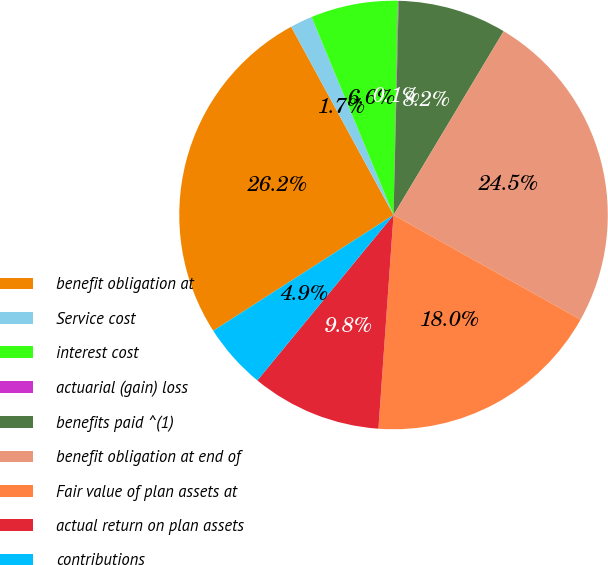Convert chart to OTSL. <chart><loc_0><loc_0><loc_500><loc_500><pie_chart><fcel>benefit obligation at<fcel>Service cost<fcel>interest cost<fcel>actuarial (gain) loss<fcel>benefits paid ^(1)<fcel>benefit obligation at end of<fcel>Fair value of plan assets at<fcel>actual return on plan assets<fcel>contributions<nl><fcel>26.16%<fcel>1.68%<fcel>6.58%<fcel>0.05%<fcel>8.21%<fcel>24.53%<fcel>18.0%<fcel>9.84%<fcel>4.95%<nl></chart> 